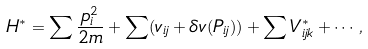<formula> <loc_0><loc_0><loc_500><loc_500>H ^ { \ast } = \sum \frac { p ^ { 2 } _ { i } } { 2 m } + \sum ( v _ { i j } + { \delta } v ( { P } _ { i j } ) ) + \sum V ^ { * } _ { i j k } + \cdots ,</formula> 